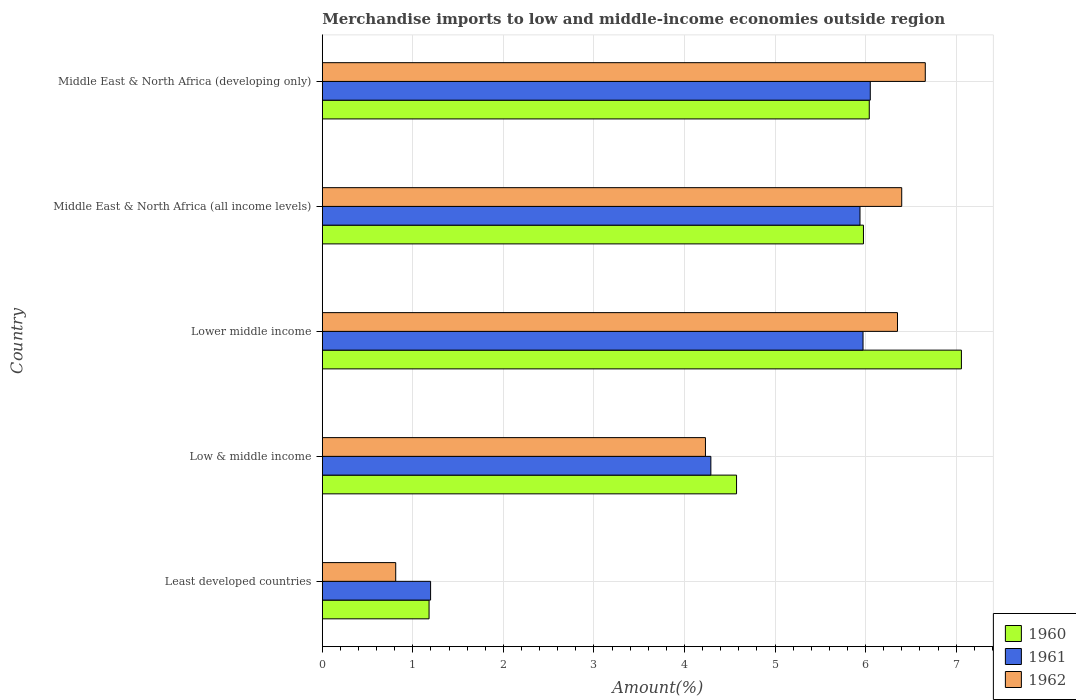How many different coloured bars are there?
Keep it short and to the point. 3. Are the number of bars per tick equal to the number of legend labels?
Your answer should be compact. Yes. How many bars are there on the 4th tick from the top?
Your answer should be compact. 3. How many bars are there on the 3rd tick from the bottom?
Give a very brief answer. 3. What is the label of the 4th group of bars from the top?
Give a very brief answer. Low & middle income. What is the percentage of amount earned from merchandise imports in 1960 in Lower middle income?
Provide a short and direct response. 7.06. Across all countries, what is the maximum percentage of amount earned from merchandise imports in 1962?
Offer a very short reply. 6.66. Across all countries, what is the minimum percentage of amount earned from merchandise imports in 1961?
Your answer should be very brief. 1.2. In which country was the percentage of amount earned from merchandise imports in 1962 maximum?
Provide a short and direct response. Middle East & North Africa (developing only). In which country was the percentage of amount earned from merchandise imports in 1961 minimum?
Make the answer very short. Least developed countries. What is the total percentage of amount earned from merchandise imports in 1960 in the graph?
Your answer should be very brief. 24.83. What is the difference between the percentage of amount earned from merchandise imports in 1961 in Least developed countries and that in Lower middle income?
Offer a very short reply. -4.78. What is the difference between the percentage of amount earned from merchandise imports in 1962 in Lower middle income and the percentage of amount earned from merchandise imports in 1960 in Least developed countries?
Give a very brief answer. 5.17. What is the average percentage of amount earned from merchandise imports in 1962 per country?
Offer a very short reply. 4.89. What is the difference between the percentage of amount earned from merchandise imports in 1960 and percentage of amount earned from merchandise imports in 1961 in Middle East & North Africa (all income levels)?
Make the answer very short. 0.04. What is the ratio of the percentage of amount earned from merchandise imports in 1961 in Least developed countries to that in Middle East & North Africa (developing only)?
Provide a succinct answer. 0.2. What is the difference between the highest and the second highest percentage of amount earned from merchandise imports in 1962?
Your answer should be compact. 0.26. What is the difference between the highest and the lowest percentage of amount earned from merchandise imports in 1961?
Offer a terse response. 4.86. What does the 1st bar from the top in Middle East & North Africa (developing only) represents?
Offer a very short reply. 1962. Is it the case that in every country, the sum of the percentage of amount earned from merchandise imports in 1960 and percentage of amount earned from merchandise imports in 1962 is greater than the percentage of amount earned from merchandise imports in 1961?
Your answer should be compact. Yes. How many bars are there?
Offer a very short reply. 15. Are all the bars in the graph horizontal?
Give a very brief answer. Yes. What is the difference between two consecutive major ticks on the X-axis?
Provide a succinct answer. 1. Does the graph contain grids?
Keep it short and to the point. Yes. Where does the legend appear in the graph?
Ensure brevity in your answer.  Bottom right. How many legend labels are there?
Make the answer very short. 3. What is the title of the graph?
Your answer should be very brief. Merchandise imports to low and middle-income economies outside region. Does "1974" appear as one of the legend labels in the graph?
Make the answer very short. No. What is the label or title of the X-axis?
Your answer should be compact. Amount(%). What is the label or title of the Y-axis?
Offer a very short reply. Country. What is the Amount(%) in 1960 in Least developed countries?
Your answer should be compact. 1.18. What is the Amount(%) of 1961 in Least developed countries?
Make the answer very short. 1.2. What is the Amount(%) in 1962 in Least developed countries?
Your answer should be very brief. 0.81. What is the Amount(%) of 1960 in Low & middle income?
Your answer should be very brief. 4.57. What is the Amount(%) in 1961 in Low & middle income?
Your answer should be compact. 4.29. What is the Amount(%) in 1962 in Low & middle income?
Provide a succinct answer. 4.23. What is the Amount(%) in 1960 in Lower middle income?
Your answer should be compact. 7.06. What is the Amount(%) in 1961 in Lower middle income?
Your answer should be very brief. 5.97. What is the Amount(%) of 1962 in Lower middle income?
Your answer should be very brief. 6.35. What is the Amount(%) of 1960 in Middle East & North Africa (all income levels)?
Give a very brief answer. 5.98. What is the Amount(%) in 1961 in Middle East & North Africa (all income levels)?
Keep it short and to the point. 5.94. What is the Amount(%) of 1962 in Middle East & North Africa (all income levels)?
Your answer should be very brief. 6.4. What is the Amount(%) in 1960 in Middle East & North Africa (developing only)?
Give a very brief answer. 6.04. What is the Amount(%) in 1961 in Middle East & North Africa (developing only)?
Keep it short and to the point. 6.05. What is the Amount(%) in 1962 in Middle East & North Africa (developing only)?
Offer a very short reply. 6.66. Across all countries, what is the maximum Amount(%) in 1960?
Your answer should be very brief. 7.06. Across all countries, what is the maximum Amount(%) of 1961?
Provide a succinct answer. 6.05. Across all countries, what is the maximum Amount(%) in 1962?
Ensure brevity in your answer.  6.66. Across all countries, what is the minimum Amount(%) of 1960?
Your answer should be compact. 1.18. Across all countries, what is the minimum Amount(%) in 1961?
Give a very brief answer. 1.2. Across all countries, what is the minimum Amount(%) of 1962?
Your answer should be compact. 0.81. What is the total Amount(%) in 1960 in the graph?
Your answer should be compact. 24.83. What is the total Amount(%) of 1961 in the graph?
Ensure brevity in your answer.  23.45. What is the total Amount(%) of 1962 in the graph?
Your answer should be compact. 24.45. What is the difference between the Amount(%) of 1960 in Least developed countries and that in Low & middle income?
Your response must be concise. -3.4. What is the difference between the Amount(%) of 1961 in Least developed countries and that in Low & middle income?
Keep it short and to the point. -3.1. What is the difference between the Amount(%) of 1962 in Least developed countries and that in Low & middle income?
Provide a short and direct response. -3.42. What is the difference between the Amount(%) of 1960 in Least developed countries and that in Lower middle income?
Your answer should be very brief. -5.88. What is the difference between the Amount(%) in 1961 in Least developed countries and that in Lower middle income?
Provide a short and direct response. -4.78. What is the difference between the Amount(%) of 1962 in Least developed countries and that in Lower middle income?
Ensure brevity in your answer.  -5.54. What is the difference between the Amount(%) in 1960 in Least developed countries and that in Middle East & North Africa (all income levels)?
Provide a short and direct response. -4.8. What is the difference between the Amount(%) of 1961 in Least developed countries and that in Middle East & North Africa (all income levels)?
Provide a succinct answer. -4.74. What is the difference between the Amount(%) of 1962 in Least developed countries and that in Middle East & North Africa (all income levels)?
Offer a very short reply. -5.59. What is the difference between the Amount(%) of 1960 in Least developed countries and that in Middle East & North Africa (developing only)?
Your answer should be compact. -4.86. What is the difference between the Amount(%) of 1961 in Least developed countries and that in Middle East & North Africa (developing only)?
Ensure brevity in your answer.  -4.86. What is the difference between the Amount(%) in 1962 in Least developed countries and that in Middle East & North Africa (developing only)?
Offer a terse response. -5.85. What is the difference between the Amount(%) in 1960 in Low & middle income and that in Lower middle income?
Provide a succinct answer. -2.48. What is the difference between the Amount(%) in 1961 in Low & middle income and that in Lower middle income?
Make the answer very short. -1.68. What is the difference between the Amount(%) of 1962 in Low & middle income and that in Lower middle income?
Your answer should be very brief. -2.12. What is the difference between the Amount(%) of 1960 in Low & middle income and that in Middle East & North Africa (all income levels)?
Your response must be concise. -1.4. What is the difference between the Amount(%) in 1961 in Low & middle income and that in Middle East & North Africa (all income levels)?
Offer a terse response. -1.65. What is the difference between the Amount(%) of 1962 in Low & middle income and that in Middle East & North Africa (all income levels)?
Your answer should be compact. -2.17. What is the difference between the Amount(%) in 1960 in Low & middle income and that in Middle East & North Africa (developing only)?
Provide a short and direct response. -1.47. What is the difference between the Amount(%) of 1961 in Low & middle income and that in Middle East & North Africa (developing only)?
Provide a succinct answer. -1.76. What is the difference between the Amount(%) of 1962 in Low & middle income and that in Middle East & North Africa (developing only)?
Provide a short and direct response. -2.43. What is the difference between the Amount(%) of 1960 in Lower middle income and that in Middle East & North Africa (all income levels)?
Provide a succinct answer. 1.08. What is the difference between the Amount(%) of 1961 in Lower middle income and that in Middle East & North Africa (all income levels)?
Offer a terse response. 0.03. What is the difference between the Amount(%) in 1962 in Lower middle income and that in Middle East & North Africa (all income levels)?
Your answer should be very brief. -0.05. What is the difference between the Amount(%) in 1960 in Lower middle income and that in Middle East & North Africa (developing only)?
Your answer should be compact. 1.02. What is the difference between the Amount(%) in 1961 in Lower middle income and that in Middle East & North Africa (developing only)?
Provide a short and direct response. -0.08. What is the difference between the Amount(%) of 1962 in Lower middle income and that in Middle East & North Africa (developing only)?
Ensure brevity in your answer.  -0.31. What is the difference between the Amount(%) of 1960 in Middle East & North Africa (all income levels) and that in Middle East & North Africa (developing only)?
Offer a terse response. -0.06. What is the difference between the Amount(%) in 1961 in Middle East & North Africa (all income levels) and that in Middle East & North Africa (developing only)?
Your answer should be very brief. -0.11. What is the difference between the Amount(%) in 1962 in Middle East & North Africa (all income levels) and that in Middle East & North Africa (developing only)?
Offer a very short reply. -0.26. What is the difference between the Amount(%) of 1960 in Least developed countries and the Amount(%) of 1961 in Low & middle income?
Ensure brevity in your answer.  -3.11. What is the difference between the Amount(%) of 1960 in Least developed countries and the Amount(%) of 1962 in Low & middle income?
Keep it short and to the point. -3.05. What is the difference between the Amount(%) in 1961 in Least developed countries and the Amount(%) in 1962 in Low & middle income?
Ensure brevity in your answer.  -3.04. What is the difference between the Amount(%) in 1960 in Least developed countries and the Amount(%) in 1961 in Lower middle income?
Keep it short and to the point. -4.79. What is the difference between the Amount(%) in 1960 in Least developed countries and the Amount(%) in 1962 in Lower middle income?
Make the answer very short. -5.17. What is the difference between the Amount(%) in 1961 in Least developed countries and the Amount(%) in 1962 in Lower middle income?
Your answer should be very brief. -5.16. What is the difference between the Amount(%) of 1960 in Least developed countries and the Amount(%) of 1961 in Middle East & North Africa (all income levels)?
Give a very brief answer. -4.76. What is the difference between the Amount(%) of 1960 in Least developed countries and the Amount(%) of 1962 in Middle East & North Africa (all income levels)?
Make the answer very short. -5.22. What is the difference between the Amount(%) in 1961 in Least developed countries and the Amount(%) in 1962 in Middle East & North Africa (all income levels)?
Keep it short and to the point. -5.2. What is the difference between the Amount(%) of 1960 in Least developed countries and the Amount(%) of 1961 in Middle East & North Africa (developing only)?
Ensure brevity in your answer.  -4.87. What is the difference between the Amount(%) in 1960 in Least developed countries and the Amount(%) in 1962 in Middle East & North Africa (developing only)?
Ensure brevity in your answer.  -5.48. What is the difference between the Amount(%) of 1961 in Least developed countries and the Amount(%) of 1962 in Middle East & North Africa (developing only)?
Your response must be concise. -5.46. What is the difference between the Amount(%) of 1960 in Low & middle income and the Amount(%) of 1961 in Lower middle income?
Keep it short and to the point. -1.4. What is the difference between the Amount(%) of 1960 in Low & middle income and the Amount(%) of 1962 in Lower middle income?
Offer a terse response. -1.78. What is the difference between the Amount(%) of 1961 in Low & middle income and the Amount(%) of 1962 in Lower middle income?
Ensure brevity in your answer.  -2.06. What is the difference between the Amount(%) of 1960 in Low & middle income and the Amount(%) of 1961 in Middle East & North Africa (all income levels)?
Provide a short and direct response. -1.36. What is the difference between the Amount(%) of 1960 in Low & middle income and the Amount(%) of 1962 in Middle East & North Africa (all income levels)?
Give a very brief answer. -1.82. What is the difference between the Amount(%) of 1961 in Low & middle income and the Amount(%) of 1962 in Middle East & North Africa (all income levels)?
Give a very brief answer. -2.11. What is the difference between the Amount(%) in 1960 in Low & middle income and the Amount(%) in 1961 in Middle East & North Africa (developing only)?
Offer a very short reply. -1.48. What is the difference between the Amount(%) in 1960 in Low & middle income and the Amount(%) in 1962 in Middle East & North Africa (developing only)?
Your answer should be compact. -2.08. What is the difference between the Amount(%) of 1961 in Low & middle income and the Amount(%) of 1962 in Middle East & North Africa (developing only)?
Give a very brief answer. -2.37. What is the difference between the Amount(%) in 1960 in Lower middle income and the Amount(%) in 1961 in Middle East & North Africa (all income levels)?
Keep it short and to the point. 1.12. What is the difference between the Amount(%) of 1960 in Lower middle income and the Amount(%) of 1962 in Middle East & North Africa (all income levels)?
Ensure brevity in your answer.  0.66. What is the difference between the Amount(%) of 1961 in Lower middle income and the Amount(%) of 1962 in Middle East & North Africa (all income levels)?
Your answer should be very brief. -0.43. What is the difference between the Amount(%) in 1960 in Lower middle income and the Amount(%) in 1961 in Middle East & North Africa (developing only)?
Offer a very short reply. 1.01. What is the difference between the Amount(%) in 1960 in Lower middle income and the Amount(%) in 1962 in Middle East & North Africa (developing only)?
Keep it short and to the point. 0.4. What is the difference between the Amount(%) of 1961 in Lower middle income and the Amount(%) of 1962 in Middle East & North Africa (developing only)?
Keep it short and to the point. -0.69. What is the difference between the Amount(%) in 1960 in Middle East & North Africa (all income levels) and the Amount(%) in 1961 in Middle East & North Africa (developing only)?
Make the answer very short. -0.08. What is the difference between the Amount(%) in 1960 in Middle East & North Africa (all income levels) and the Amount(%) in 1962 in Middle East & North Africa (developing only)?
Your response must be concise. -0.68. What is the difference between the Amount(%) of 1961 in Middle East & North Africa (all income levels) and the Amount(%) of 1962 in Middle East & North Africa (developing only)?
Your response must be concise. -0.72. What is the average Amount(%) of 1960 per country?
Offer a very short reply. 4.97. What is the average Amount(%) of 1961 per country?
Your answer should be compact. 4.69. What is the average Amount(%) of 1962 per country?
Your answer should be compact. 4.89. What is the difference between the Amount(%) of 1960 and Amount(%) of 1961 in Least developed countries?
Offer a terse response. -0.02. What is the difference between the Amount(%) of 1960 and Amount(%) of 1962 in Least developed countries?
Ensure brevity in your answer.  0.37. What is the difference between the Amount(%) in 1961 and Amount(%) in 1962 in Least developed countries?
Give a very brief answer. 0.39. What is the difference between the Amount(%) of 1960 and Amount(%) of 1961 in Low & middle income?
Provide a short and direct response. 0.28. What is the difference between the Amount(%) in 1960 and Amount(%) in 1962 in Low & middle income?
Keep it short and to the point. 0.34. What is the difference between the Amount(%) of 1961 and Amount(%) of 1962 in Low & middle income?
Keep it short and to the point. 0.06. What is the difference between the Amount(%) in 1960 and Amount(%) in 1961 in Lower middle income?
Keep it short and to the point. 1.09. What is the difference between the Amount(%) of 1960 and Amount(%) of 1962 in Lower middle income?
Provide a succinct answer. 0.71. What is the difference between the Amount(%) of 1961 and Amount(%) of 1962 in Lower middle income?
Offer a terse response. -0.38. What is the difference between the Amount(%) of 1960 and Amount(%) of 1961 in Middle East & North Africa (all income levels)?
Offer a terse response. 0.04. What is the difference between the Amount(%) in 1960 and Amount(%) in 1962 in Middle East & North Africa (all income levels)?
Offer a very short reply. -0.42. What is the difference between the Amount(%) in 1961 and Amount(%) in 1962 in Middle East & North Africa (all income levels)?
Keep it short and to the point. -0.46. What is the difference between the Amount(%) of 1960 and Amount(%) of 1961 in Middle East & North Africa (developing only)?
Your answer should be compact. -0.01. What is the difference between the Amount(%) in 1960 and Amount(%) in 1962 in Middle East & North Africa (developing only)?
Offer a terse response. -0.62. What is the difference between the Amount(%) in 1961 and Amount(%) in 1962 in Middle East & North Africa (developing only)?
Provide a short and direct response. -0.61. What is the ratio of the Amount(%) of 1960 in Least developed countries to that in Low & middle income?
Make the answer very short. 0.26. What is the ratio of the Amount(%) in 1961 in Least developed countries to that in Low & middle income?
Your response must be concise. 0.28. What is the ratio of the Amount(%) in 1962 in Least developed countries to that in Low & middle income?
Offer a very short reply. 0.19. What is the ratio of the Amount(%) of 1960 in Least developed countries to that in Lower middle income?
Provide a succinct answer. 0.17. What is the ratio of the Amount(%) of 1961 in Least developed countries to that in Lower middle income?
Your answer should be very brief. 0.2. What is the ratio of the Amount(%) in 1962 in Least developed countries to that in Lower middle income?
Provide a short and direct response. 0.13. What is the ratio of the Amount(%) of 1960 in Least developed countries to that in Middle East & North Africa (all income levels)?
Offer a terse response. 0.2. What is the ratio of the Amount(%) of 1961 in Least developed countries to that in Middle East & North Africa (all income levels)?
Provide a short and direct response. 0.2. What is the ratio of the Amount(%) of 1962 in Least developed countries to that in Middle East & North Africa (all income levels)?
Give a very brief answer. 0.13. What is the ratio of the Amount(%) of 1960 in Least developed countries to that in Middle East & North Africa (developing only)?
Make the answer very short. 0.2. What is the ratio of the Amount(%) of 1961 in Least developed countries to that in Middle East & North Africa (developing only)?
Offer a very short reply. 0.2. What is the ratio of the Amount(%) in 1962 in Least developed countries to that in Middle East & North Africa (developing only)?
Ensure brevity in your answer.  0.12. What is the ratio of the Amount(%) of 1960 in Low & middle income to that in Lower middle income?
Your response must be concise. 0.65. What is the ratio of the Amount(%) in 1961 in Low & middle income to that in Lower middle income?
Provide a short and direct response. 0.72. What is the ratio of the Amount(%) of 1962 in Low & middle income to that in Lower middle income?
Your response must be concise. 0.67. What is the ratio of the Amount(%) of 1960 in Low & middle income to that in Middle East & North Africa (all income levels)?
Your response must be concise. 0.77. What is the ratio of the Amount(%) in 1961 in Low & middle income to that in Middle East & North Africa (all income levels)?
Give a very brief answer. 0.72. What is the ratio of the Amount(%) of 1962 in Low & middle income to that in Middle East & North Africa (all income levels)?
Give a very brief answer. 0.66. What is the ratio of the Amount(%) of 1960 in Low & middle income to that in Middle East & North Africa (developing only)?
Make the answer very short. 0.76. What is the ratio of the Amount(%) of 1961 in Low & middle income to that in Middle East & North Africa (developing only)?
Your answer should be compact. 0.71. What is the ratio of the Amount(%) of 1962 in Low & middle income to that in Middle East & North Africa (developing only)?
Give a very brief answer. 0.64. What is the ratio of the Amount(%) of 1960 in Lower middle income to that in Middle East & North Africa (all income levels)?
Keep it short and to the point. 1.18. What is the ratio of the Amount(%) in 1961 in Lower middle income to that in Middle East & North Africa (all income levels)?
Your answer should be very brief. 1.01. What is the ratio of the Amount(%) of 1960 in Lower middle income to that in Middle East & North Africa (developing only)?
Your answer should be compact. 1.17. What is the ratio of the Amount(%) of 1961 in Lower middle income to that in Middle East & North Africa (developing only)?
Make the answer very short. 0.99. What is the ratio of the Amount(%) of 1962 in Lower middle income to that in Middle East & North Africa (developing only)?
Offer a terse response. 0.95. What is the ratio of the Amount(%) of 1961 in Middle East & North Africa (all income levels) to that in Middle East & North Africa (developing only)?
Provide a succinct answer. 0.98. What is the ratio of the Amount(%) of 1962 in Middle East & North Africa (all income levels) to that in Middle East & North Africa (developing only)?
Your answer should be very brief. 0.96. What is the difference between the highest and the second highest Amount(%) in 1960?
Provide a succinct answer. 1.02. What is the difference between the highest and the second highest Amount(%) in 1961?
Make the answer very short. 0.08. What is the difference between the highest and the second highest Amount(%) in 1962?
Your answer should be compact. 0.26. What is the difference between the highest and the lowest Amount(%) of 1960?
Make the answer very short. 5.88. What is the difference between the highest and the lowest Amount(%) of 1961?
Offer a very short reply. 4.86. What is the difference between the highest and the lowest Amount(%) of 1962?
Make the answer very short. 5.85. 